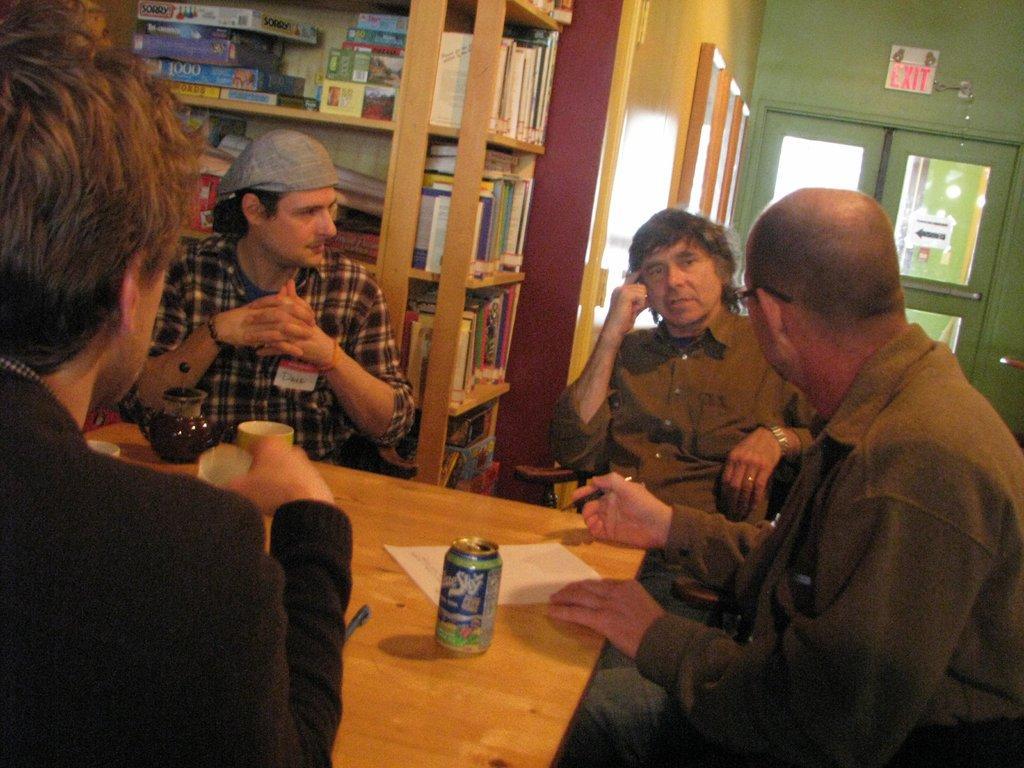In one or two sentences, can you explain what this image depicts? On the background we can see a wall, door and exit board. Here we can see a rack and all the books are arranged. We can see few persons sitting on chairs in front of a table and on the table we can see paper, tin, cups, and jar. We can see this man is holding a pen in his hand. 